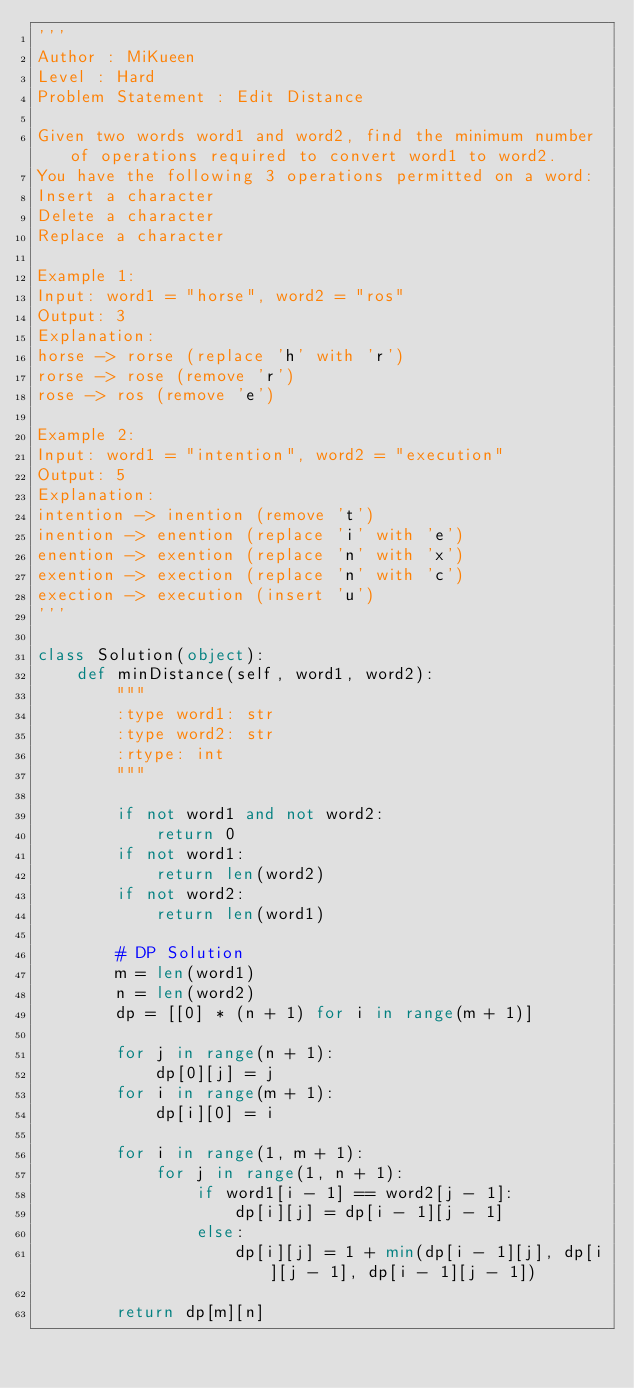<code> <loc_0><loc_0><loc_500><loc_500><_Python_>'''
Author : MiKueen
Level : Hard
Problem Statement : Edit Distance

Given two words word1 and word2, find the minimum number of operations required to convert word1 to word2.
You have the following 3 operations permitted on a word:
Insert a character
Delete a character
Replace a character

Example 1:
Input: word1 = "horse", word2 = "ros"
Output: 3
Explanation: 
horse -> rorse (replace 'h' with 'r')
rorse -> rose (remove 'r')
rose -> ros (remove 'e')

Example 2:
Input: word1 = "intention", word2 = "execution"
Output: 5
Explanation: 
intention -> inention (remove 't')
inention -> enention (replace 'i' with 'e')
enention -> exention (replace 'n' with 'x')
exention -> exection (replace 'n' with 'c')
exection -> execution (insert 'u')
'''

class Solution(object):
    def minDistance(self, word1, word2):
        """
        :type word1: str
        :type word2: str
        :rtype: int
        """
        
        if not word1 and not word2:
            return 0
        if not word1:
            return len(word2)
        if not word2:
            return len(word1)
        
        # DP Solution
        m = len(word1)
        n = len(word2)
        dp = [[0] * (n + 1) for i in range(m + 1)]

        for j in range(n + 1):
            dp[0][j] = j
        for i in range(m + 1):
            dp[i][0] = i

        for i in range(1, m + 1):
            for j in range(1, n + 1):
                if word1[i - 1] == word2[j - 1]:
                    dp[i][j] = dp[i - 1][j - 1]
                else:
                    dp[i][j] = 1 + min(dp[i - 1][j], dp[i][j - 1], dp[i - 1][j - 1])
        
        return dp[m][n]
        </code> 